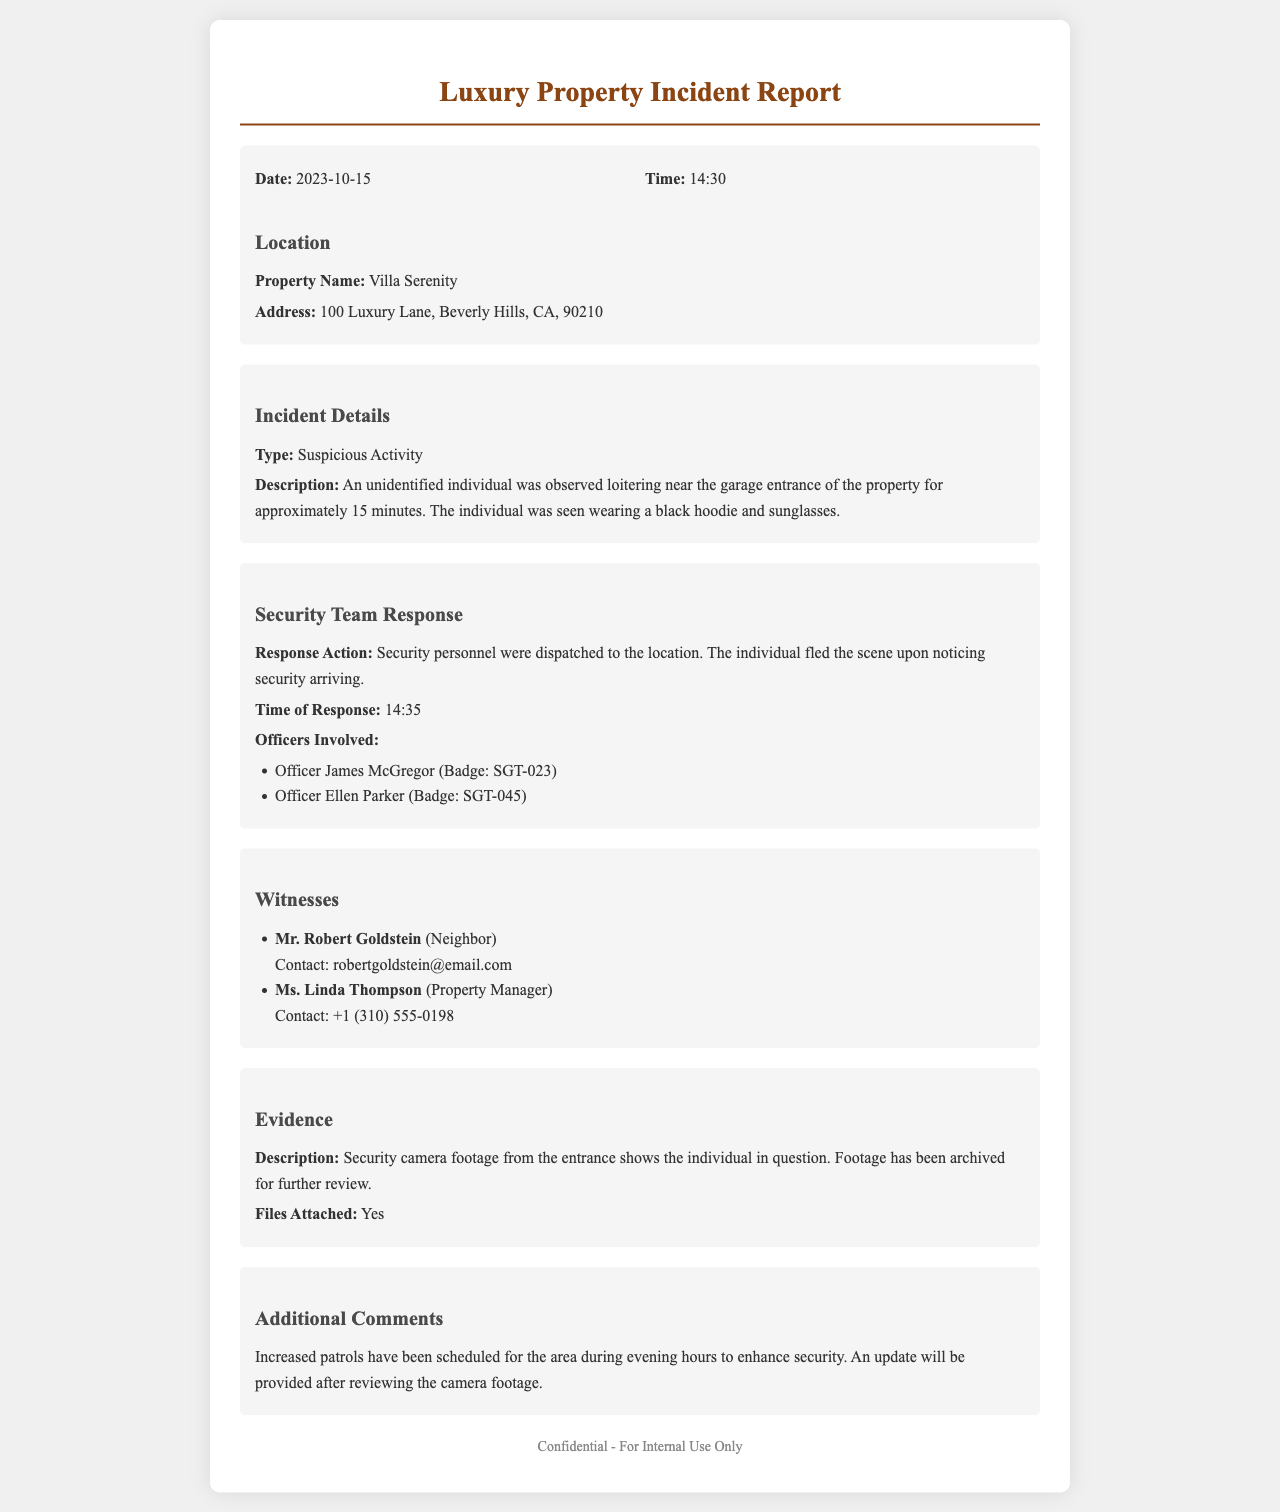what date did the incident occur? The date of the incident is specifically mentioned in the document.
Answer: 2023-10-15 what time did the suspicious activity take place? The time of the incident is provided in the document.
Answer: 14:30 what was the property name involved in the incident? The name of the property where the incident occurred is stated clearly.
Answer: Villa Serenity how many officers were involved in the response? The document lists the officers involved in the incident response.
Answer: 2 what item of evidence was mentioned in the report? The evidence related to the incident is detailed in the report.
Answer: Security camera footage what was the reason for increased patrols? The document provides reasoning for the security actions taken after the incident.
Answer: Enhance security what clothing description was given for the suspicious individual? The document mentions specific details regarding the suspect's attire.
Answer: Black hoodie and sunglasses who was the property manager witness? A specific witness is identified in the document as the property manager.
Answer: Ms. Linda Thompson when was the security response initiated? The document specifies the time when security personnel responded to the incident.
Answer: 14:35 